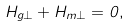Convert formula to latex. <formula><loc_0><loc_0><loc_500><loc_500>H _ { g \perp } + H _ { m \perp } = 0 ,</formula> 